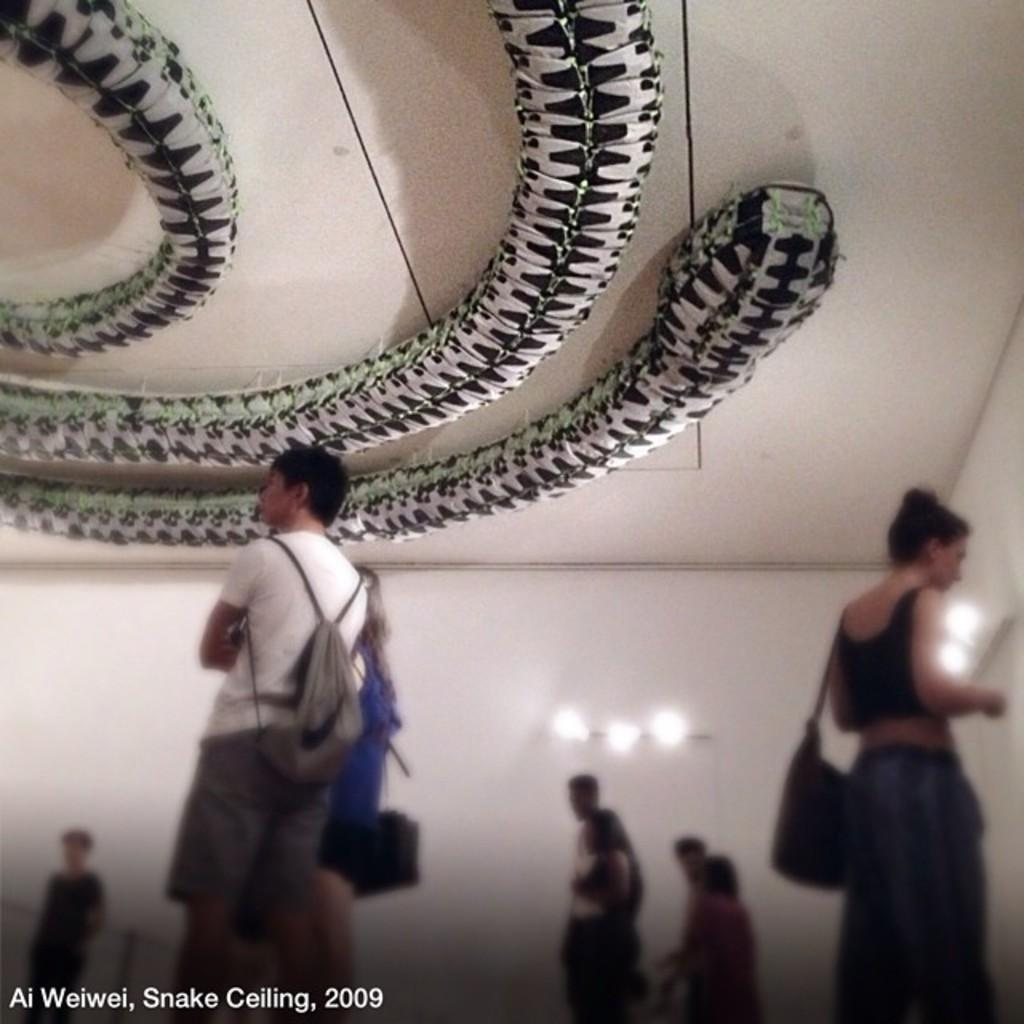What can be seen in the image? There are people standing in the image. Where are the people standing? The people are standing on the floor. What can be seen on the wall in the background of the image? There are lights attached to the wall in the background of the image. What type of basin is being used in the process depicted in the image? There is no basin or process present in the image; it only shows people standing on the floor with lights on the wall in the background. 